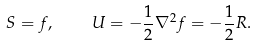<formula> <loc_0><loc_0><loc_500><loc_500>S = f , \quad U = - \frac { 1 } { 2 } \nabla ^ { 2 } f = - \frac { 1 } { 2 } R .</formula> 